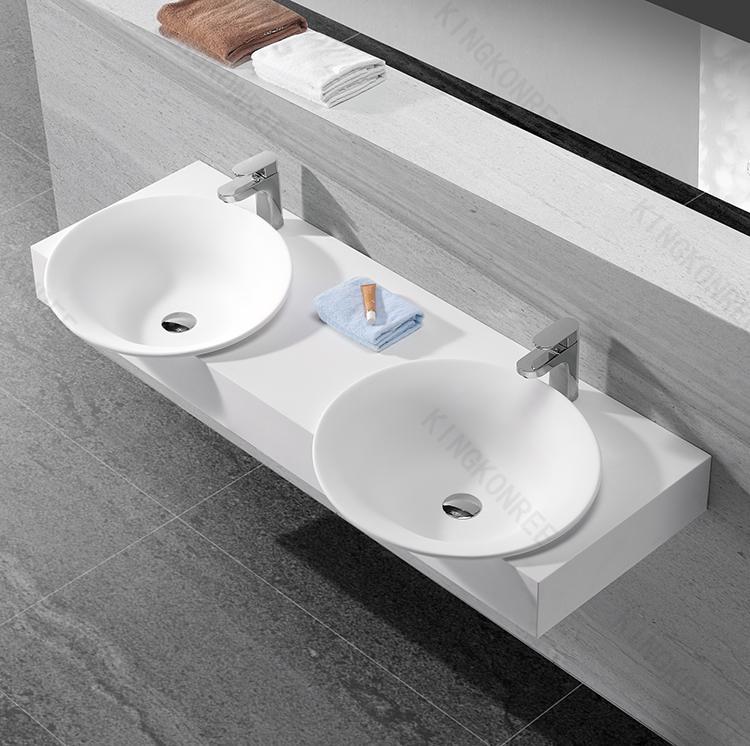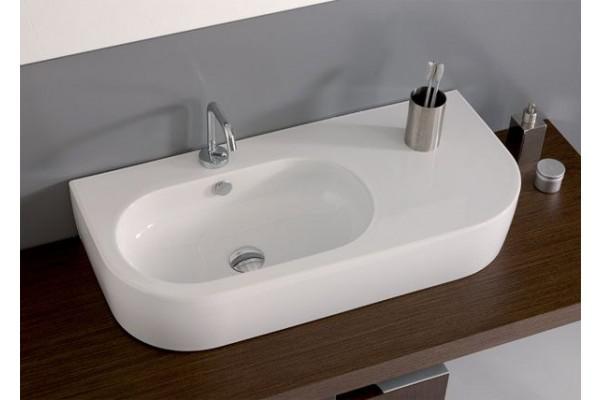The first image is the image on the left, the second image is the image on the right. For the images shown, is this caption "The left image shows one rectangular sink which is inset and has a wide counter, and the right image shows a sink that is more square and does not have a wide counter." true? Answer yes or no. No. The first image is the image on the left, the second image is the image on the right. Examine the images to the left and right. Is the description "Each sink is rectangular" accurate? Answer yes or no. No. 